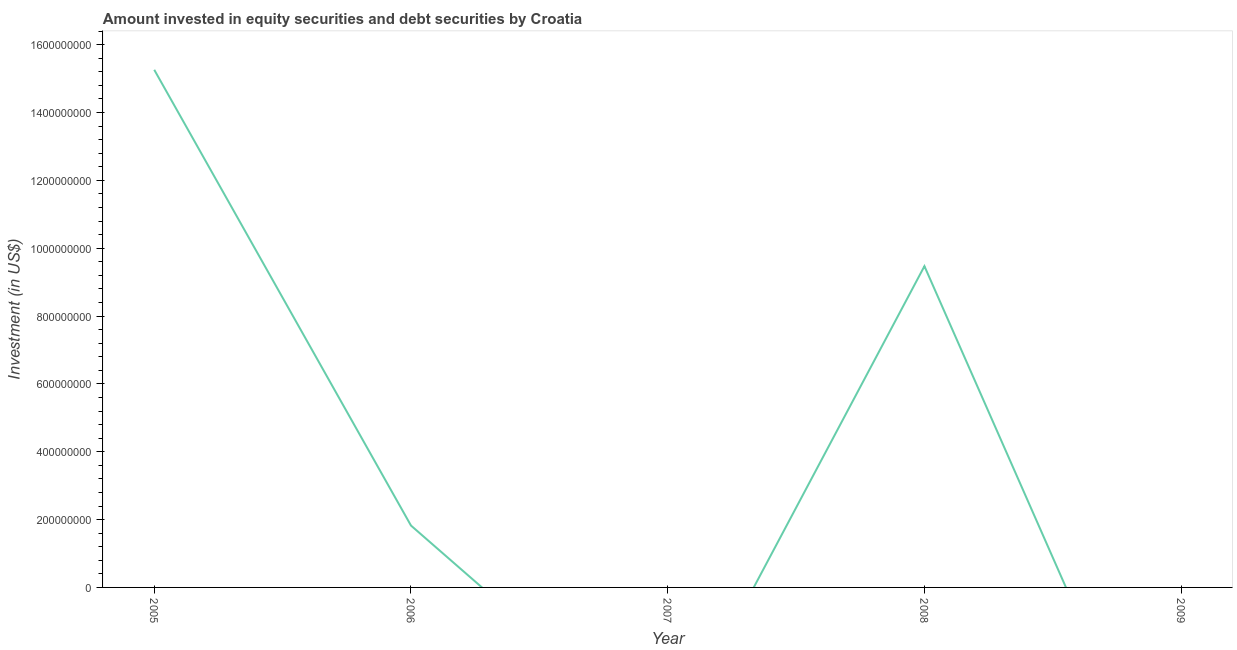What is the portfolio investment in 2006?
Offer a very short reply. 1.82e+08. Across all years, what is the maximum portfolio investment?
Give a very brief answer. 1.53e+09. In which year was the portfolio investment maximum?
Your answer should be compact. 2005. What is the sum of the portfolio investment?
Your response must be concise. 2.66e+09. What is the difference between the portfolio investment in 2005 and 2008?
Your answer should be very brief. 5.79e+08. What is the average portfolio investment per year?
Make the answer very short. 5.31e+08. What is the median portfolio investment?
Provide a succinct answer. 1.82e+08. What is the ratio of the portfolio investment in 2006 to that in 2008?
Ensure brevity in your answer.  0.19. Is the difference between the portfolio investment in 2006 and 2008 greater than the difference between any two years?
Provide a short and direct response. No. What is the difference between the highest and the second highest portfolio investment?
Your response must be concise. 5.79e+08. What is the difference between the highest and the lowest portfolio investment?
Ensure brevity in your answer.  1.53e+09. Does the portfolio investment monotonically increase over the years?
Provide a succinct answer. No. Are the values on the major ticks of Y-axis written in scientific E-notation?
Give a very brief answer. No. Does the graph contain any zero values?
Offer a terse response. Yes. What is the title of the graph?
Your response must be concise. Amount invested in equity securities and debt securities by Croatia. What is the label or title of the X-axis?
Offer a very short reply. Year. What is the label or title of the Y-axis?
Ensure brevity in your answer.  Investment (in US$). What is the Investment (in US$) in 2005?
Your answer should be very brief. 1.53e+09. What is the Investment (in US$) in 2006?
Provide a short and direct response. 1.82e+08. What is the Investment (in US$) in 2007?
Your response must be concise. 0. What is the Investment (in US$) in 2008?
Ensure brevity in your answer.  9.47e+08. What is the Investment (in US$) of 2009?
Keep it short and to the point. 0. What is the difference between the Investment (in US$) in 2005 and 2006?
Provide a short and direct response. 1.34e+09. What is the difference between the Investment (in US$) in 2005 and 2008?
Offer a very short reply. 5.79e+08. What is the difference between the Investment (in US$) in 2006 and 2008?
Make the answer very short. -7.65e+08. What is the ratio of the Investment (in US$) in 2005 to that in 2006?
Keep it short and to the point. 8.37. What is the ratio of the Investment (in US$) in 2005 to that in 2008?
Your response must be concise. 1.61. What is the ratio of the Investment (in US$) in 2006 to that in 2008?
Provide a short and direct response. 0.19. 